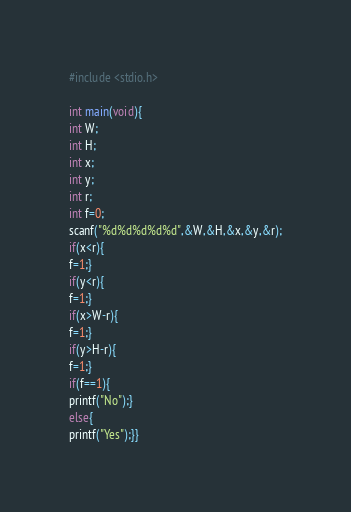<code> <loc_0><loc_0><loc_500><loc_500><_C_>#include <stdio.h>

int main(void){
int W;
int H;
int x;
int y;
int r;
int f=0;
scanf("%d%d%d%d%d",&W,&H,&x,&y,&r);
if(x<r){
f=1;}
if(y<r){
f=1;}
if(x>W-r){
f=1;}
if(y>H-r){
f=1;}
if(f==1){
printf("No");}
else{
printf("Yes");}}
</code> 